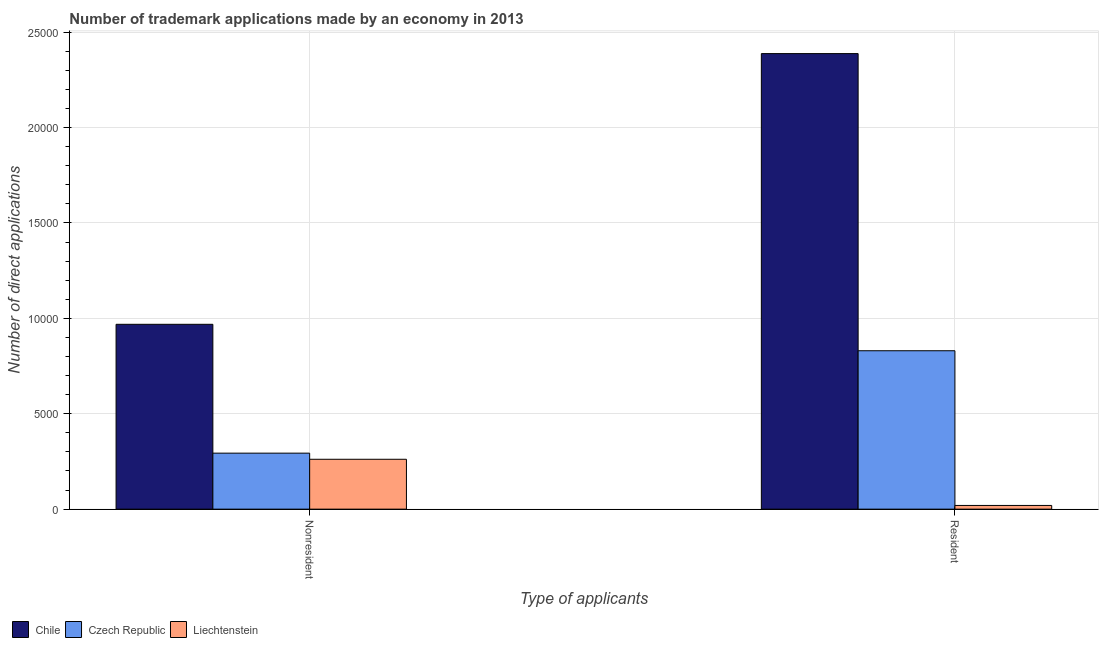How many different coloured bars are there?
Ensure brevity in your answer.  3. Are the number of bars per tick equal to the number of legend labels?
Offer a terse response. Yes. Are the number of bars on each tick of the X-axis equal?
Your answer should be compact. Yes. How many bars are there on the 1st tick from the left?
Offer a very short reply. 3. What is the label of the 2nd group of bars from the left?
Offer a very short reply. Resident. What is the number of trademark applications made by residents in Czech Republic?
Give a very brief answer. 8302. Across all countries, what is the maximum number of trademark applications made by non residents?
Give a very brief answer. 9688. Across all countries, what is the minimum number of trademark applications made by non residents?
Ensure brevity in your answer.  2614. In which country was the number of trademark applications made by residents minimum?
Provide a short and direct response. Liechtenstein. What is the total number of trademark applications made by residents in the graph?
Offer a terse response. 3.24e+04. What is the difference between the number of trademark applications made by non residents in Czech Republic and that in Liechtenstein?
Keep it short and to the point. 321. What is the difference between the number of trademark applications made by non residents in Chile and the number of trademark applications made by residents in Czech Republic?
Offer a terse response. 1386. What is the average number of trademark applications made by residents per country?
Make the answer very short. 1.08e+04. What is the difference between the number of trademark applications made by non residents and number of trademark applications made by residents in Chile?
Keep it short and to the point. -1.42e+04. What is the ratio of the number of trademark applications made by non residents in Czech Republic to that in Liechtenstein?
Your answer should be compact. 1.12. Is the number of trademark applications made by non residents in Liechtenstein less than that in Czech Republic?
Offer a terse response. Yes. In how many countries, is the number of trademark applications made by non residents greater than the average number of trademark applications made by non residents taken over all countries?
Your answer should be very brief. 1. What does the 1st bar from the right in Resident represents?
Give a very brief answer. Liechtenstein. How many bars are there?
Ensure brevity in your answer.  6. Are all the bars in the graph horizontal?
Offer a very short reply. No. What is the difference between two consecutive major ticks on the Y-axis?
Make the answer very short. 5000. Are the values on the major ticks of Y-axis written in scientific E-notation?
Offer a very short reply. No. Where does the legend appear in the graph?
Offer a very short reply. Bottom left. What is the title of the graph?
Your response must be concise. Number of trademark applications made by an economy in 2013. Does "Armenia" appear as one of the legend labels in the graph?
Provide a short and direct response. No. What is the label or title of the X-axis?
Give a very brief answer. Type of applicants. What is the label or title of the Y-axis?
Give a very brief answer. Number of direct applications. What is the Number of direct applications of Chile in Nonresident?
Offer a terse response. 9688. What is the Number of direct applications in Czech Republic in Nonresident?
Provide a succinct answer. 2935. What is the Number of direct applications of Liechtenstein in Nonresident?
Offer a terse response. 2614. What is the Number of direct applications in Chile in Resident?
Offer a very short reply. 2.39e+04. What is the Number of direct applications of Czech Republic in Resident?
Make the answer very short. 8302. What is the Number of direct applications in Liechtenstein in Resident?
Make the answer very short. 194. Across all Type of applicants, what is the maximum Number of direct applications of Chile?
Offer a very short reply. 2.39e+04. Across all Type of applicants, what is the maximum Number of direct applications of Czech Republic?
Provide a short and direct response. 8302. Across all Type of applicants, what is the maximum Number of direct applications of Liechtenstein?
Offer a very short reply. 2614. Across all Type of applicants, what is the minimum Number of direct applications of Chile?
Your answer should be compact. 9688. Across all Type of applicants, what is the minimum Number of direct applications in Czech Republic?
Your answer should be very brief. 2935. Across all Type of applicants, what is the minimum Number of direct applications in Liechtenstein?
Offer a terse response. 194. What is the total Number of direct applications in Chile in the graph?
Your answer should be very brief. 3.36e+04. What is the total Number of direct applications of Czech Republic in the graph?
Provide a short and direct response. 1.12e+04. What is the total Number of direct applications of Liechtenstein in the graph?
Offer a very short reply. 2808. What is the difference between the Number of direct applications of Chile in Nonresident and that in Resident?
Your response must be concise. -1.42e+04. What is the difference between the Number of direct applications in Czech Republic in Nonresident and that in Resident?
Make the answer very short. -5367. What is the difference between the Number of direct applications in Liechtenstein in Nonresident and that in Resident?
Your answer should be very brief. 2420. What is the difference between the Number of direct applications of Chile in Nonresident and the Number of direct applications of Czech Republic in Resident?
Your response must be concise. 1386. What is the difference between the Number of direct applications in Chile in Nonresident and the Number of direct applications in Liechtenstein in Resident?
Your answer should be compact. 9494. What is the difference between the Number of direct applications of Czech Republic in Nonresident and the Number of direct applications of Liechtenstein in Resident?
Your answer should be very brief. 2741. What is the average Number of direct applications of Chile per Type of applicants?
Your answer should be compact. 1.68e+04. What is the average Number of direct applications of Czech Republic per Type of applicants?
Keep it short and to the point. 5618.5. What is the average Number of direct applications of Liechtenstein per Type of applicants?
Give a very brief answer. 1404. What is the difference between the Number of direct applications in Chile and Number of direct applications in Czech Republic in Nonresident?
Your answer should be compact. 6753. What is the difference between the Number of direct applications in Chile and Number of direct applications in Liechtenstein in Nonresident?
Keep it short and to the point. 7074. What is the difference between the Number of direct applications in Czech Republic and Number of direct applications in Liechtenstein in Nonresident?
Ensure brevity in your answer.  321. What is the difference between the Number of direct applications of Chile and Number of direct applications of Czech Republic in Resident?
Keep it short and to the point. 1.56e+04. What is the difference between the Number of direct applications of Chile and Number of direct applications of Liechtenstein in Resident?
Ensure brevity in your answer.  2.37e+04. What is the difference between the Number of direct applications in Czech Republic and Number of direct applications in Liechtenstein in Resident?
Give a very brief answer. 8108. What is the ratio of the Number of direct applications in Chile in Nonresident to that in Resident?
Ensure brevity in your answer.  0.41. What is the ratio of the Number of direct applications in Czech Republic in Nonresident to that in Resident?
Offer a very short reply. 0.35. What is the ratio of the Number of direct applications of Liechtenstein in Nonresident to that in Resident?
Your response must be concise. 13.47. What is the difference between the highest and the second highest Number of direct applications of Chile?
Your response must be concise. 1.42e+04. What is the difference between the highest and the second highest Number of direct applications in Czech Republic?
Provide a succinct answer. 5367. What is the difference between the highest and the second highest Number of direct applications in Liechtenstein?
Provide a short and direct response. 2420. What is the difference between the highest and the lowest Number of direct applications in Chile?
Give a very brief answer. 1.42e+04. What is the difference between the highest and the lowest Number of direct applications of Czech Republic?
Make the answer very short. 5367. What is the difference between the highest and the lowest Number of direct applications of Liechtenstein?
Ensure brevity in your answer.  2420. 